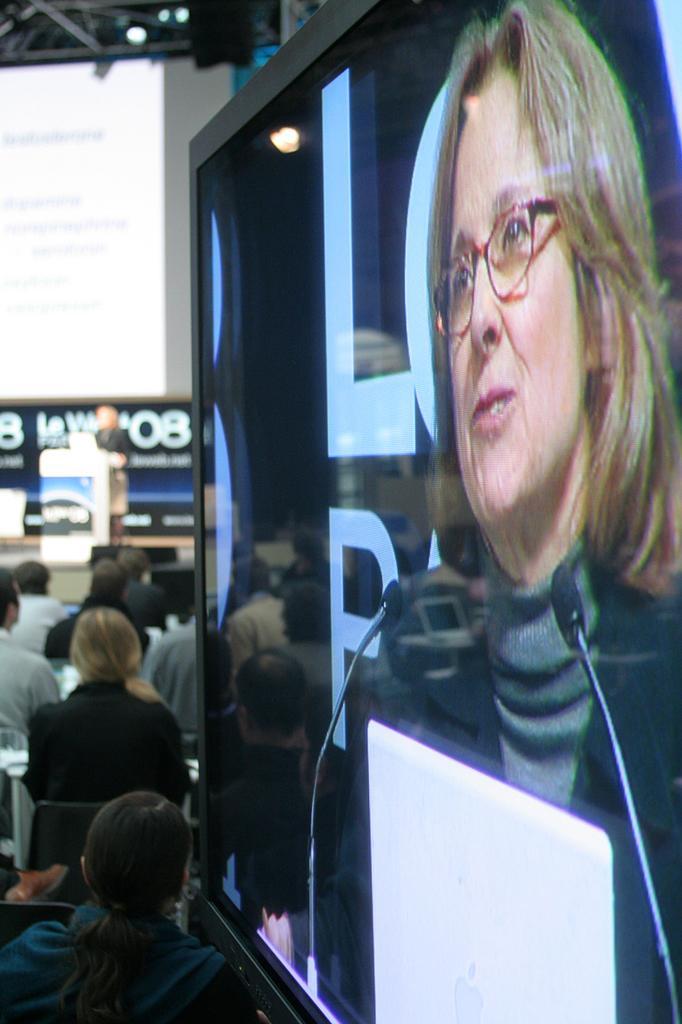Could you give a brief overview of what you see in this image? In this picture we can see some people sitting on chairs, on the right side there is a screen, we can see a woman in the screen, in the background we can see a person standing in front of a podium, we can see a light here, there is a screen here. 